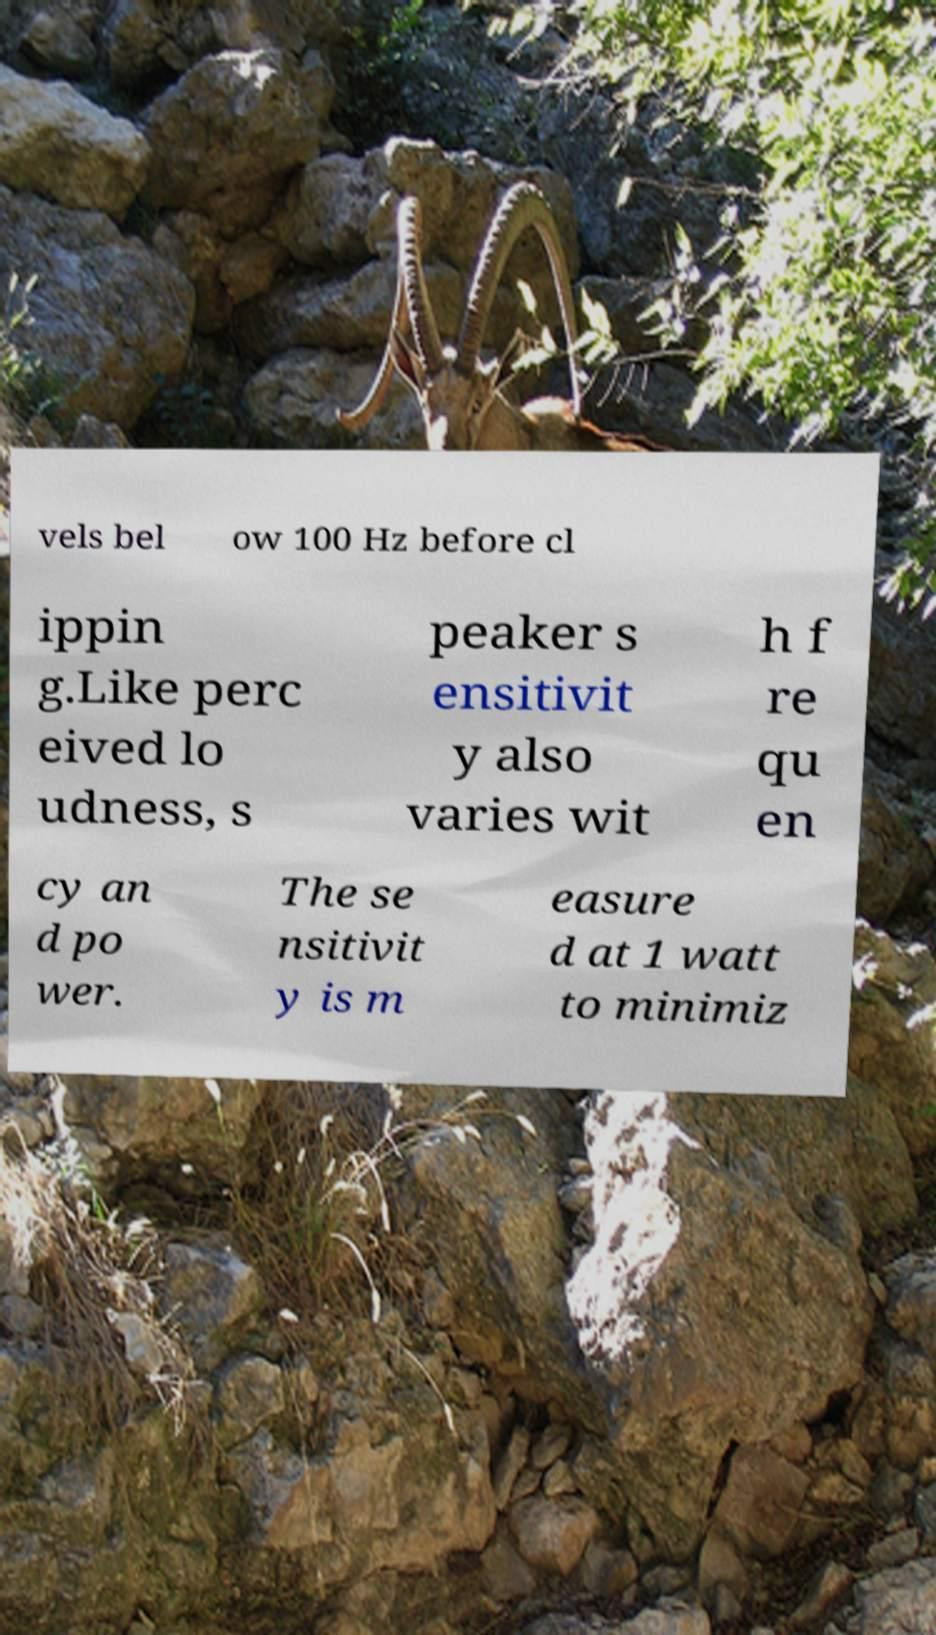Please identify and transcribe the text found in this image. vels bel ow 100 Hz before cl ippin g.Like perc eived lo udness, s peaker s ensitivit y also varies wit h f re qu en cy an d po wer. The se nsitivit y is m easure d at 1 watt to minimiz 